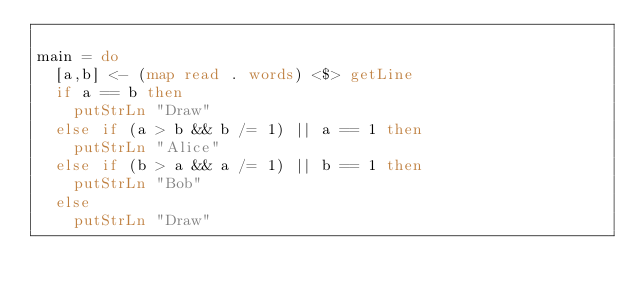<code> <loc_0><loc_0><loc_500><loc_500><_Haskell_>
main = do
  [a,b] <- (map read . words) <$> getLine
  if a == b then
    putStrLn "Draw"
  else if (a > b && b /= 1) || a == 1 then
    putStrLn "Alice"
  else if (b > a && a /= 1) || b == 1 then
    putStrLn "Bob"
  else
    putStrLn "Draw"

</code> 